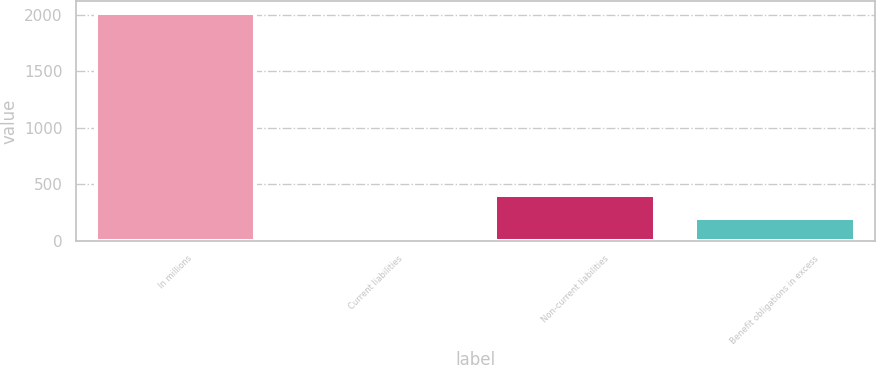Convert chart to OTSL. <chart><loc_0><loc_0><loc_500><loc_500><bar_chart><fcel>In millions<fcel>Current liabilities<fcel>Non-current liabilities<fcel>Benefit obligations in excess<nl><fcel>2017<fcel>3.6<fcel>406.28<fcel>204.94<nl></chart> 